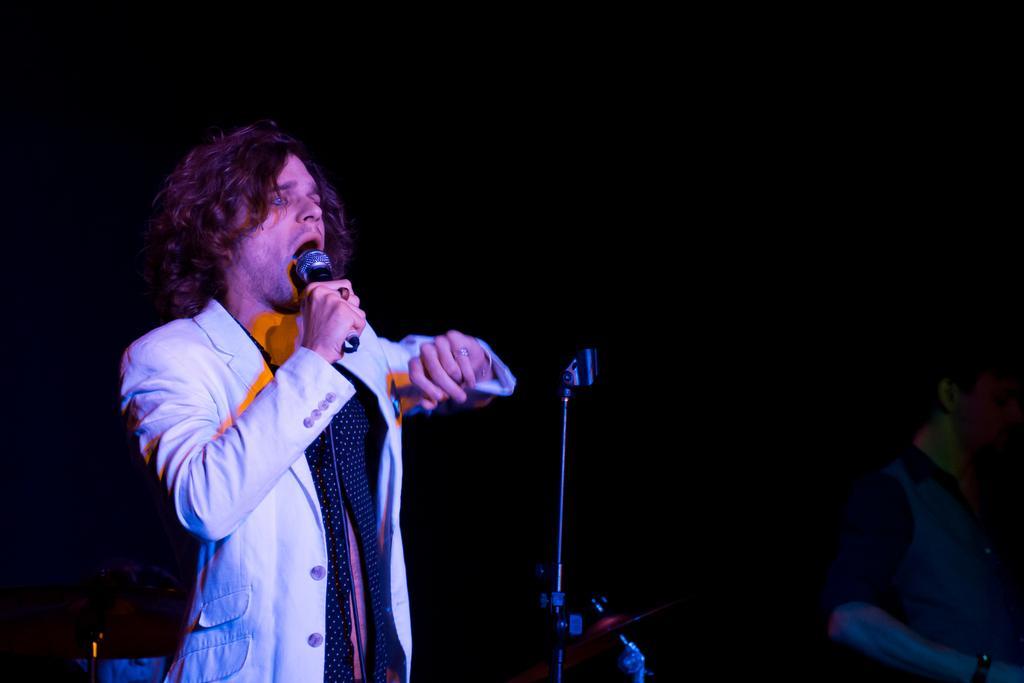Please provide a concise description of this image. In the picture I can see a person wearing black color blazer and shirt is standing here and holding a mic in his hands. The background of the image is dark, where I can see the mic stand and the person on the right side of the image. 